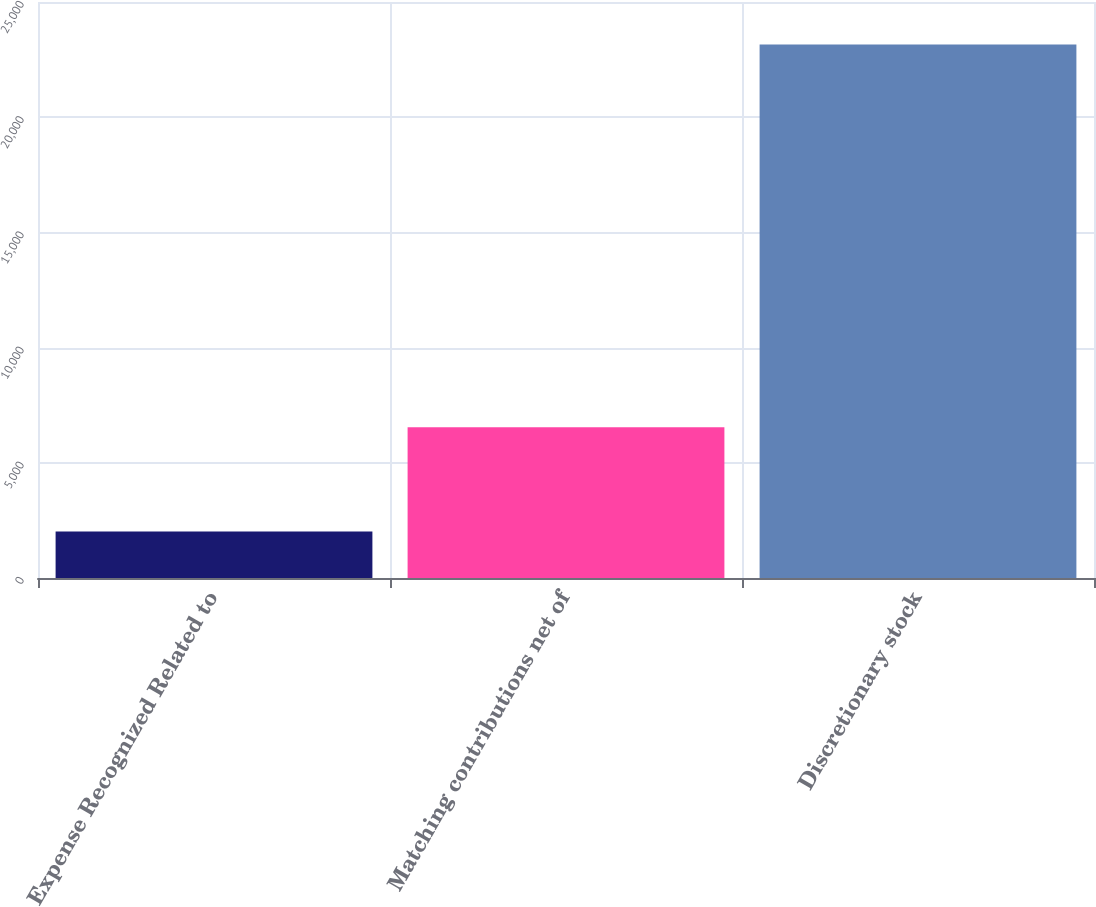Convert chart. <chart><loc_0><loc_0><loc_500><loc_500><bar_chart><fcel>Expense Recognized Related to<fcel>Matching contributions net of<fcel>Discretionary stock<nl><fcel>2016<fcel>6546<fcel>23158<nl></chart> 